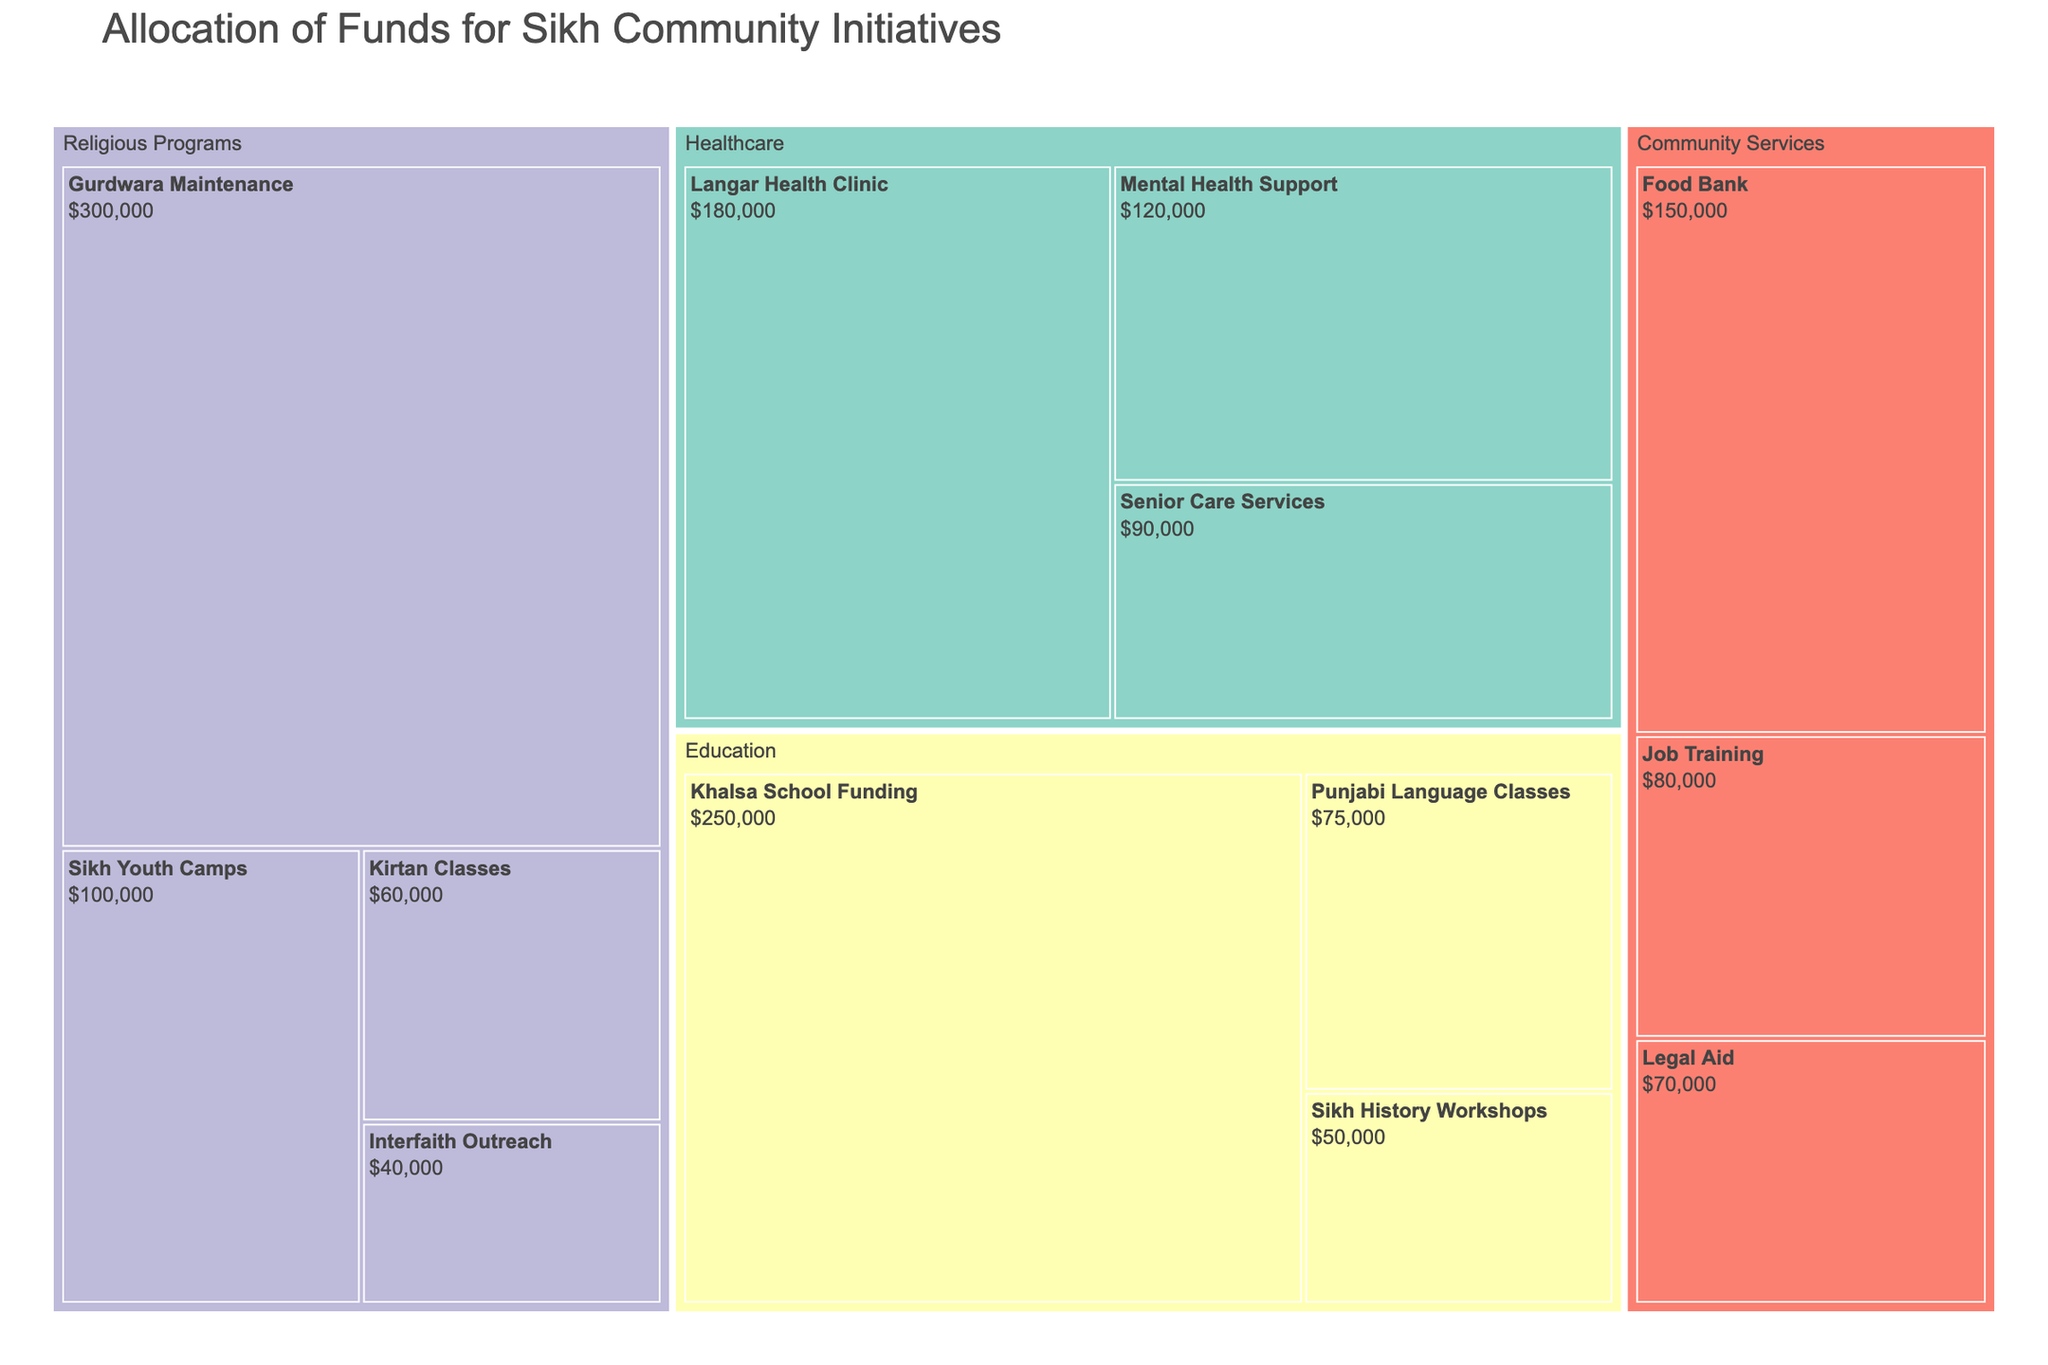Which category received the highest allocation of funds? The category with the largest segment in the treemap represents the one with the highest allocation. By visual inspection, "Religious Programs" occupies the largest area.
Answer: Religious Programs What is the amount allocated to the Khalsa School Funding? Locate the "Khalsa School Funding" subcategory within the "Education" category. The treemap indicates the allocated amount as $250,000.
Answer: $250,000 How much more is allocated to Gurdwara Maintenance compared to Punjabi Language Classes? Identify the segments for "Gurdwara Maintenance" ($300,000) and "Punjabi Language Classes" ($75,000). Subtract the latter from the former: $300,000 - $75,000 = $225,000.
Answer: $225,000 Which subcategory in Healthcare has the least amount allocated? Examine the "Healthcare" category in the treemap. The smallest subcategory by area is "Senior Care Services" with $90,000 allocated.
Answer: Senior Care Services What is the total allocation for the Education category? Add the amounts of all subcategories within "Education": $250,000 (Khalsa School Funding) + $75,000 (Punjabi Language Classes) + $50,000 (Sikh History Workshops) = $375,000.
Answer: $375,000 Which subcategory under Community Services has the highest funding? Look at the "Community Services" category and find the subcategory with the largest area, which is "Food Bank" with $150,000.
Answer: Food Bank How does the allocation for Senior Care Services compare to Interfaith Outreach? Check their respective values. "Senior Care Services" has $90,000 and "Interfaith Outreach" has $40,000. $90,000 is more than $40,000.
Answer: Senior Care Services has more funding Calculate the total allocation for all subcategories under Religious Programs. Sum the amounts given for "Gurdwara Maintenance" ($300,000), "Kirtan Classes" ($60,000), "Sikh Youth Camps" ($100,000), and "Interfaith Outreach" ($40,000): $300,000 + $60,000 + $100,000 + $40,000 = $500,000.
Answer: $500,000 Which category has the most even distribution of funds among its subcategories? Examine the sections and their relative sizes within each category. "Community Services" appears to have a more balanced distribution among "Food Bank" ($150,000), "Job Training" ($80,000), and "Legal Aid" ($70,000).
Answer: Community Services 